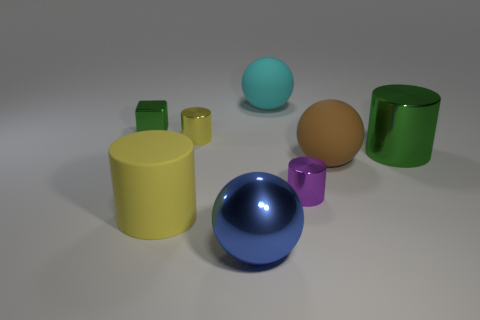Subtract all big blue balls. How many balls are left? 2 Subtract all blocks. How many objects are left? 7 Subtract all green cylinders. How many cylinders are left? 3 Add 2 brown matte balls. How many objects exist? 10 Subtract 1 cylinders. How many cylinders are left? 3 Subtract all cyan cylinders. Subtract all brown cubes. How many cylinders are left? 4 Subtract all green cylinders. How many brown spheres are left? 1 Subtract all small cyan matte cylinders. Subtract all yellow metallic cylinders. How many objects are left? 7 Add 4 cylinders. How many cylinders are left? 8 Add 5 brown metal cylinders. How many brown metal cylinders exist? 5 